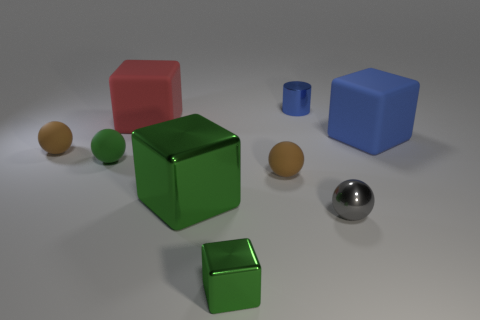Is there any pattern to the lighting in the scene? The lighting in the scene appears diffuse and soft, likely from an overhead source. It casts gentle shadows directly underneath the objects, highlighting their shapes without creating harsh contrasts. 